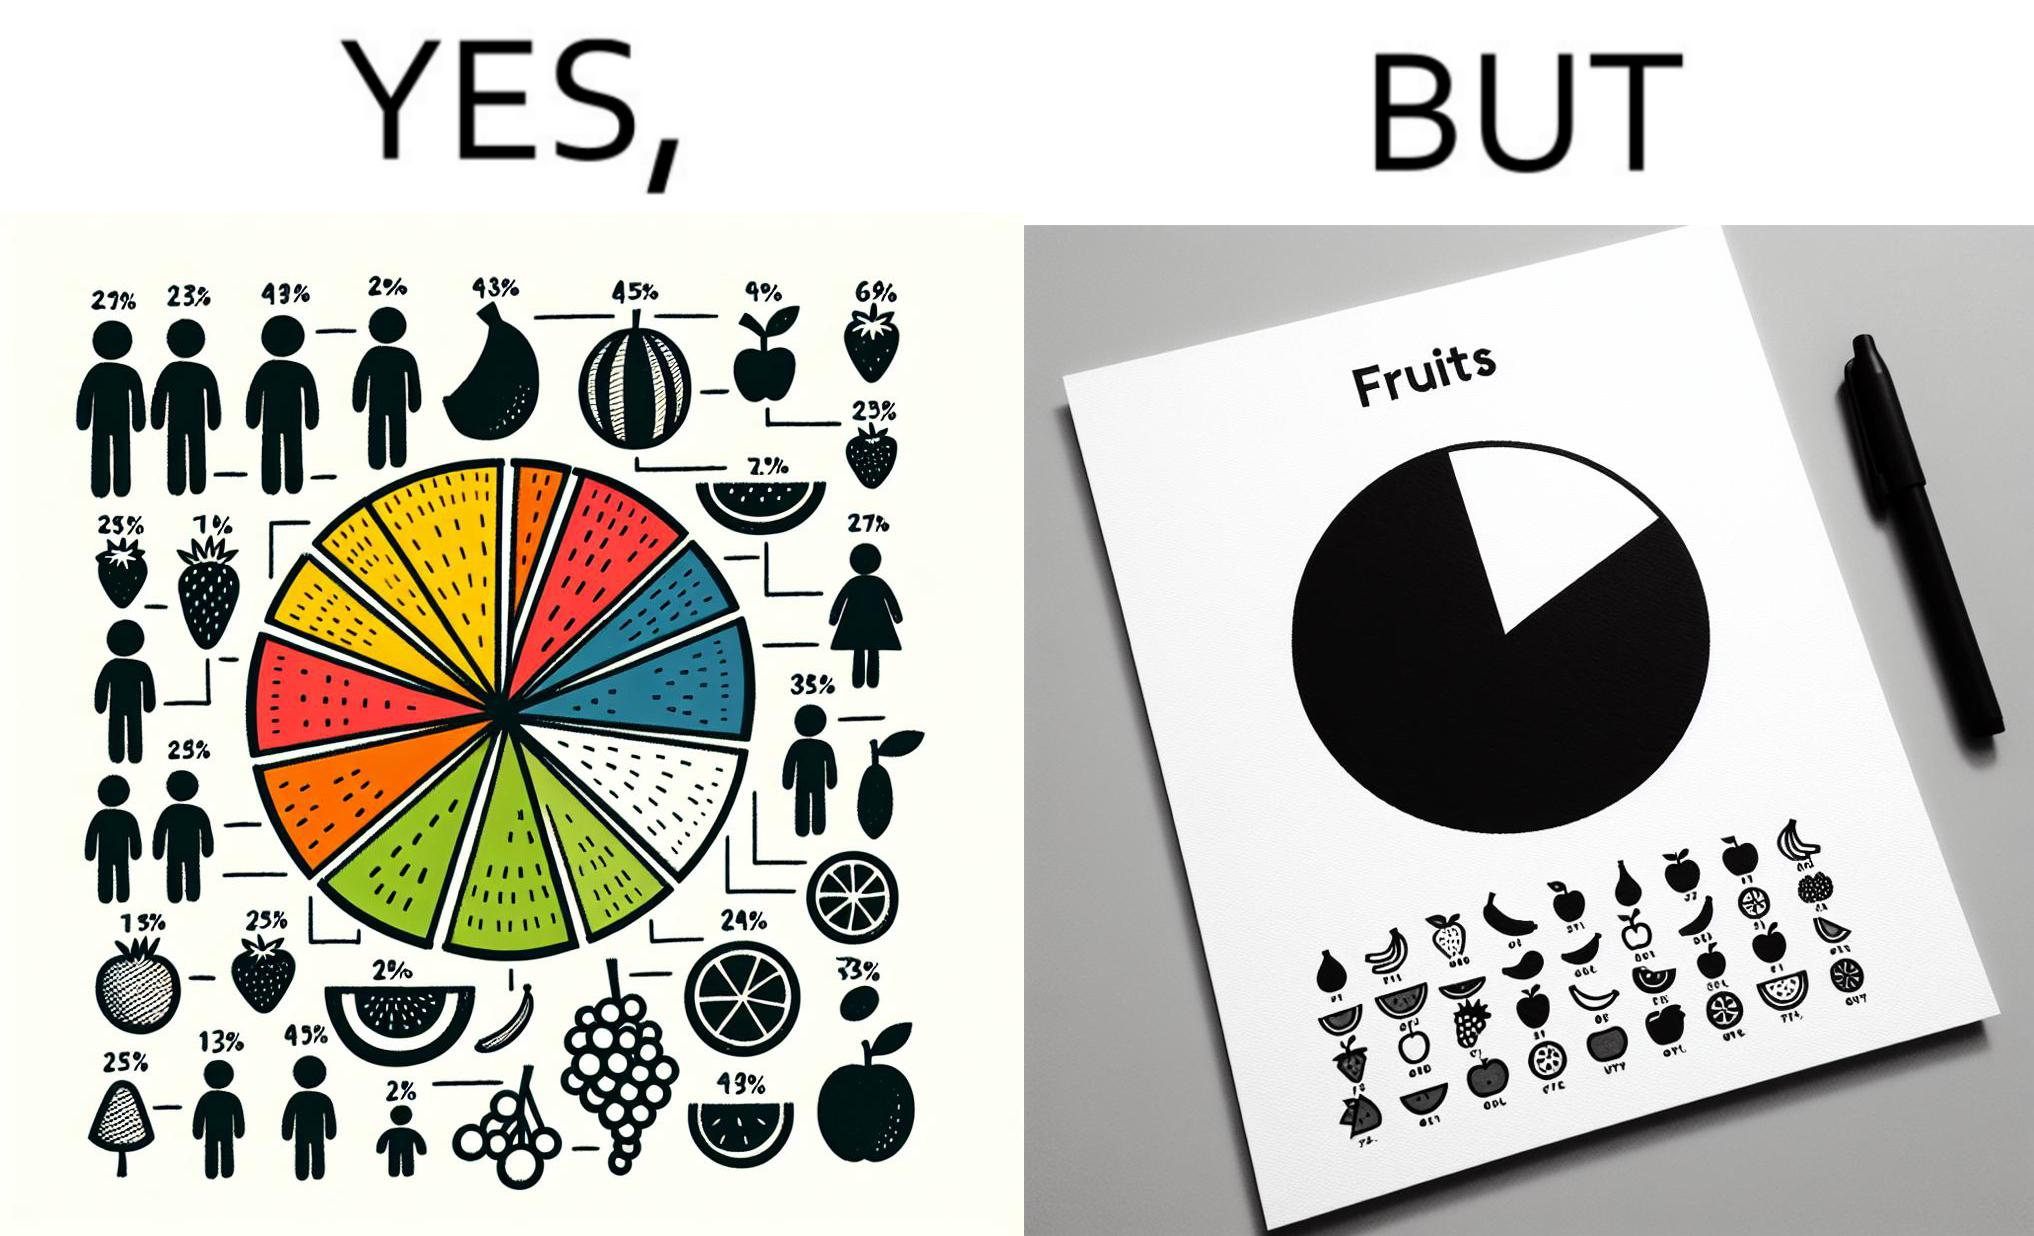Would you classify this image as satirical? Yes, this image is satirical. 